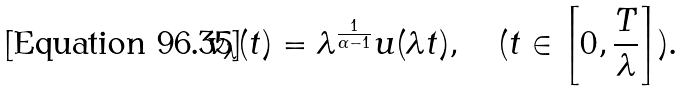<formula> <loc_0><loc_0><loc_500><loc_500>v _ { \lambda } ( t ) = \lambda ^ { \frac { 1 } { \alpha - 1 } } u ( \lambda t ) , \quad ( t \in \left [ 0 , \frac { T } { \lambda } \right ] ) .</formula> 